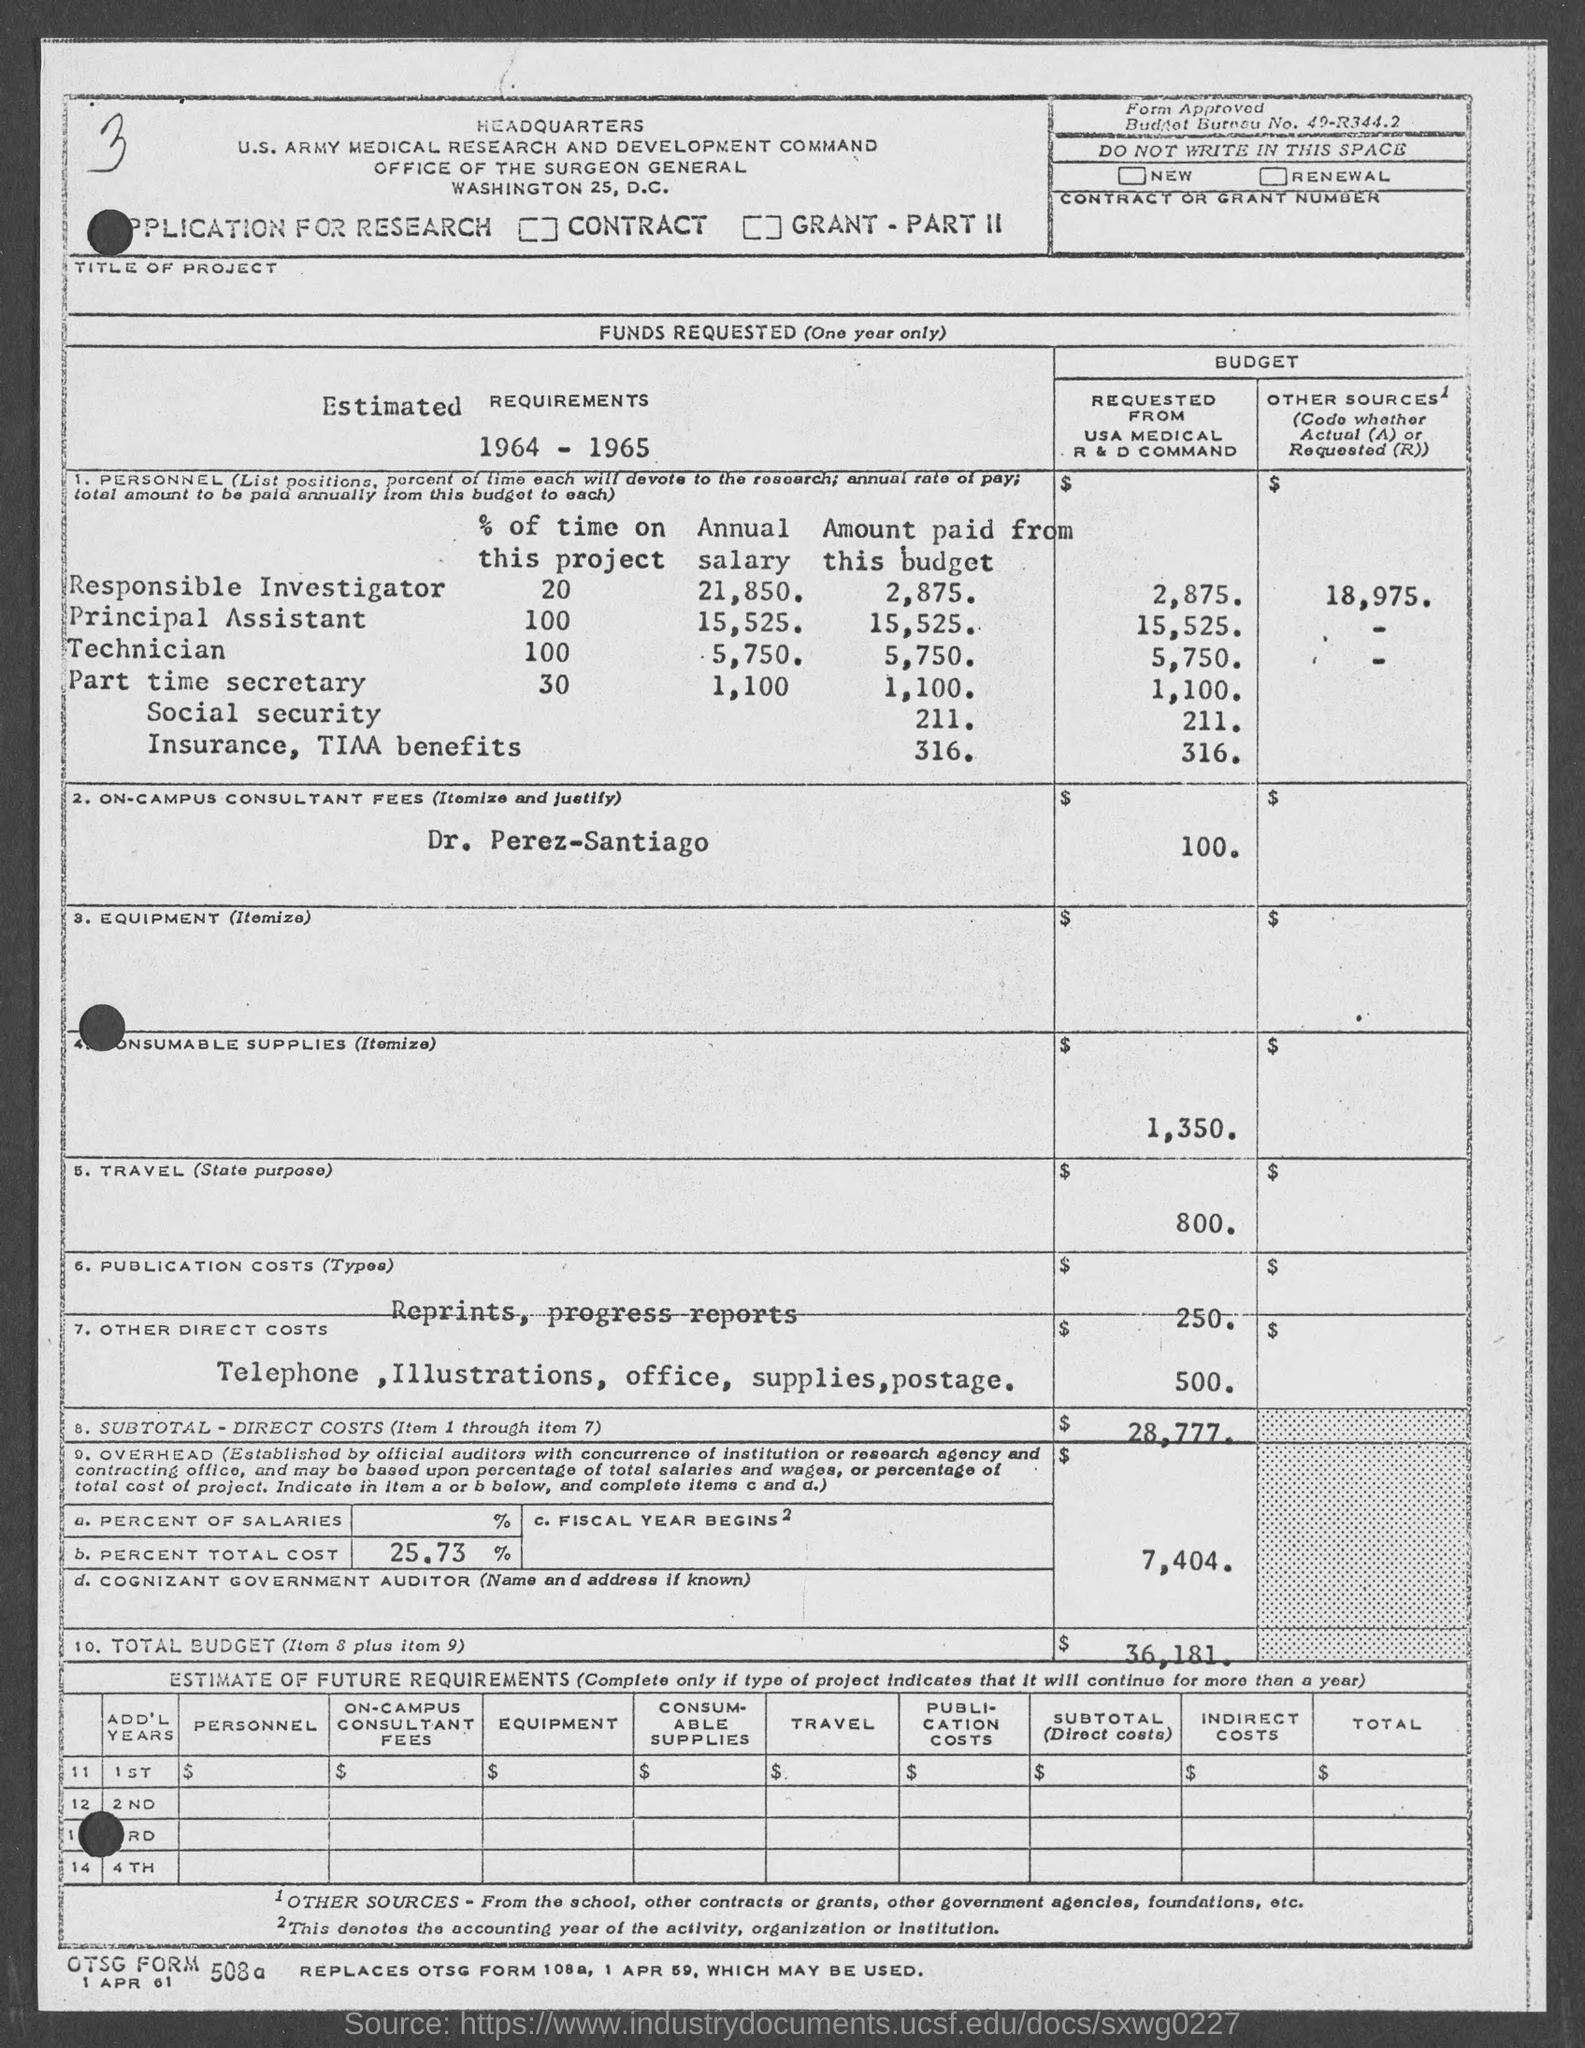Identify some key points in this picture. The annual salary for the principal assistant mentioned on the given page is 15,525. The subtotal of direct costs is $28,777 according to the given page. The amount for other costs, as mentioned in the given page, is $500. The annual salary for the technician, as mentioned on the given page, is 5,750. The amount for travel mentioned in the given page is $800. 